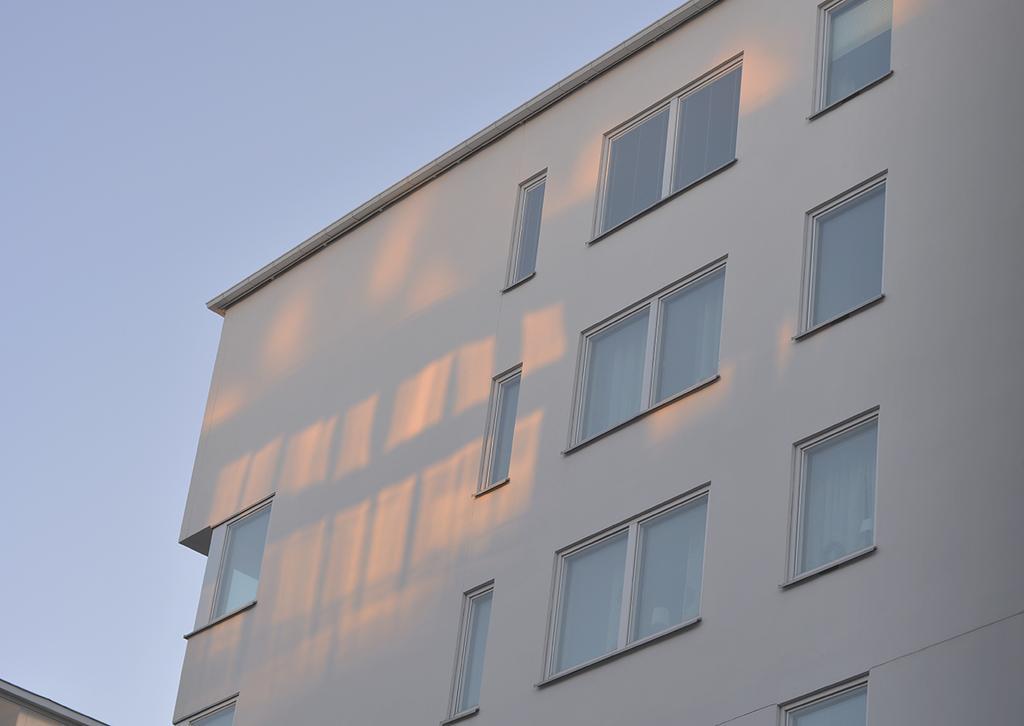Describe this image in one or two sentences. In this image we can see a building with glass windows. In the background of the image there is the sky. On the left side bottom of the image it looks like a wall. 